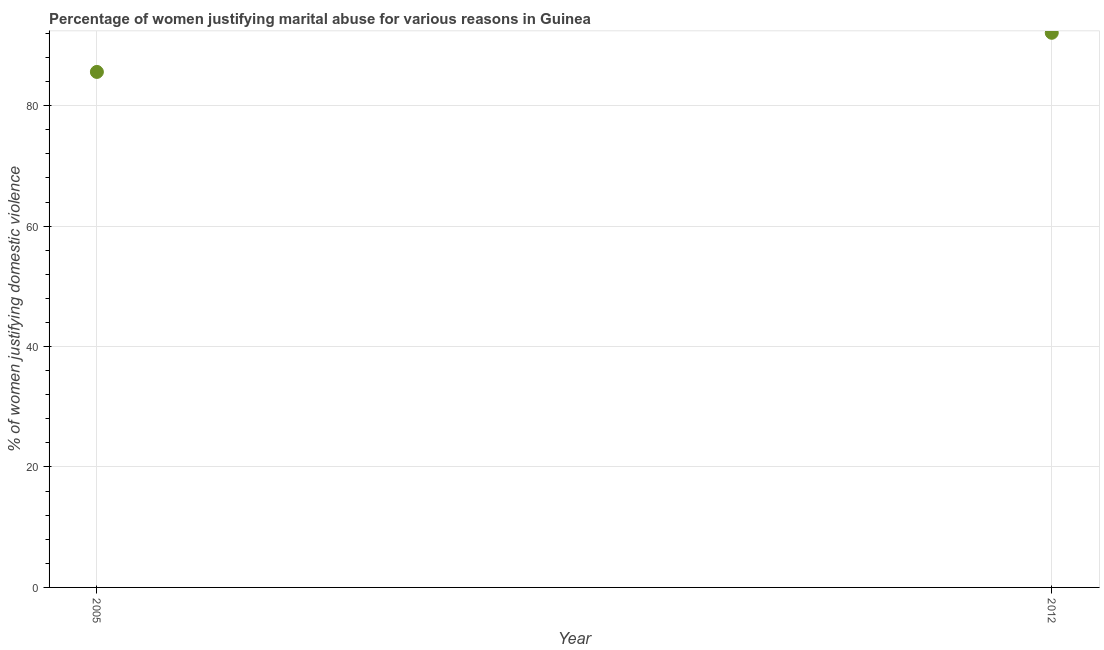What is the percentage of women justifying marital abuse in 2005?
Keep it short and to the point. 85.6. Across all years, what is the maximum percentage of women justifying marital abuse?
Offer a terse response. 92.1. Across all years, what is the minimum percentage of women justifying marital abuse?
Make the answer very short. 85.6. What is the sum of the percentage of women justifying marital abuse?
Keep it short and to the point. 177.7. What is the difference between the percentage of women justifying marital abuse in 2005 and 2012?
Your response must be concise. -6.5. What is the average percentage of women justifying marital abuse per year?
Provide a succinct answer. 88.85. What is the median percentage of women justifying marital abuse?
Ensure brevity in your answer.  88.85. Do a majority of the years between 2012 and 2005 (inclusive) have percentage of women justifying marital abuse greater than 32 %?
Provide a short and direct response. No. What is the ratio of the percentage of women justifying marital abuse in 2005 to that in 2012?
Offer a terse response. 0.93. In how many years, is the percentage of women justifying marital abuse greater than the average percentage of women justifying marital abuse taken over all years?
Make the answer very short. 1. How many years are there in the graph?
Offer a very short reply. 2. What is the difference between two consecutive major ticks on the Y-axis?
Your answer should be compact. 20. Does the graph contain any zero values?
Provide a short and direct response. No. Does the graph contain grids?
Offer a terse response. Yes. What is the title of the graph?
Keep it short and to the point. Percentage of women justifying marital abuse for various reasons in Guinea. What is the label or title of the Y-axis?
Keep it short and to the point. % of women justifying domestic violence. What is the % of women justifying domestic violence in 2005?
Provide a short and direct response. 85.6. What is the % of women justifying domestic violence in 2012?
Your response must be concise. 92.1. What is the difference between the % of women justifying domestic violence in 2005 and 2012?
Your answer should be very brief. -6.5. What is the ratio of the % of women justifying domestic violence in 2005 to that in 2012?
Keep it short and to the point. 0.93. 